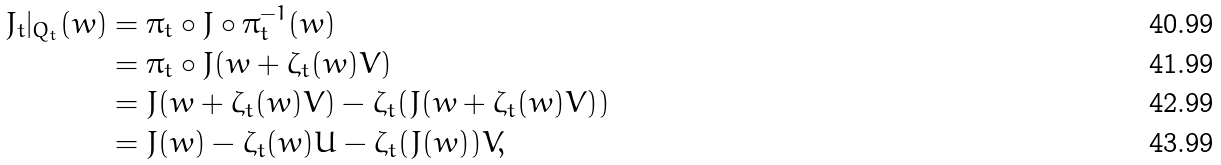<formula> <loc_0><loc_0><loc_500><loc_500>J _ { t } | _ { Q _ { t } } ( w ) & = \pi _ { t } \circ J \circ \pi _ { t } ^ { - 1 } ( w ) \\ & = \pi _ { t } \circ J ( w + \zeta _ { t } ( w ) V ) \\ & = J ( w + \zeta _ { t } ( w ) V ) - \zeta _ { t } ( J ( w + \zeta _ { t } ( w ) V ) ) \\ & = J ( w ) - \zeta _ { t } ( w ) U - \zeta _ { t } ( J ( w ) ) V ,</formula> 